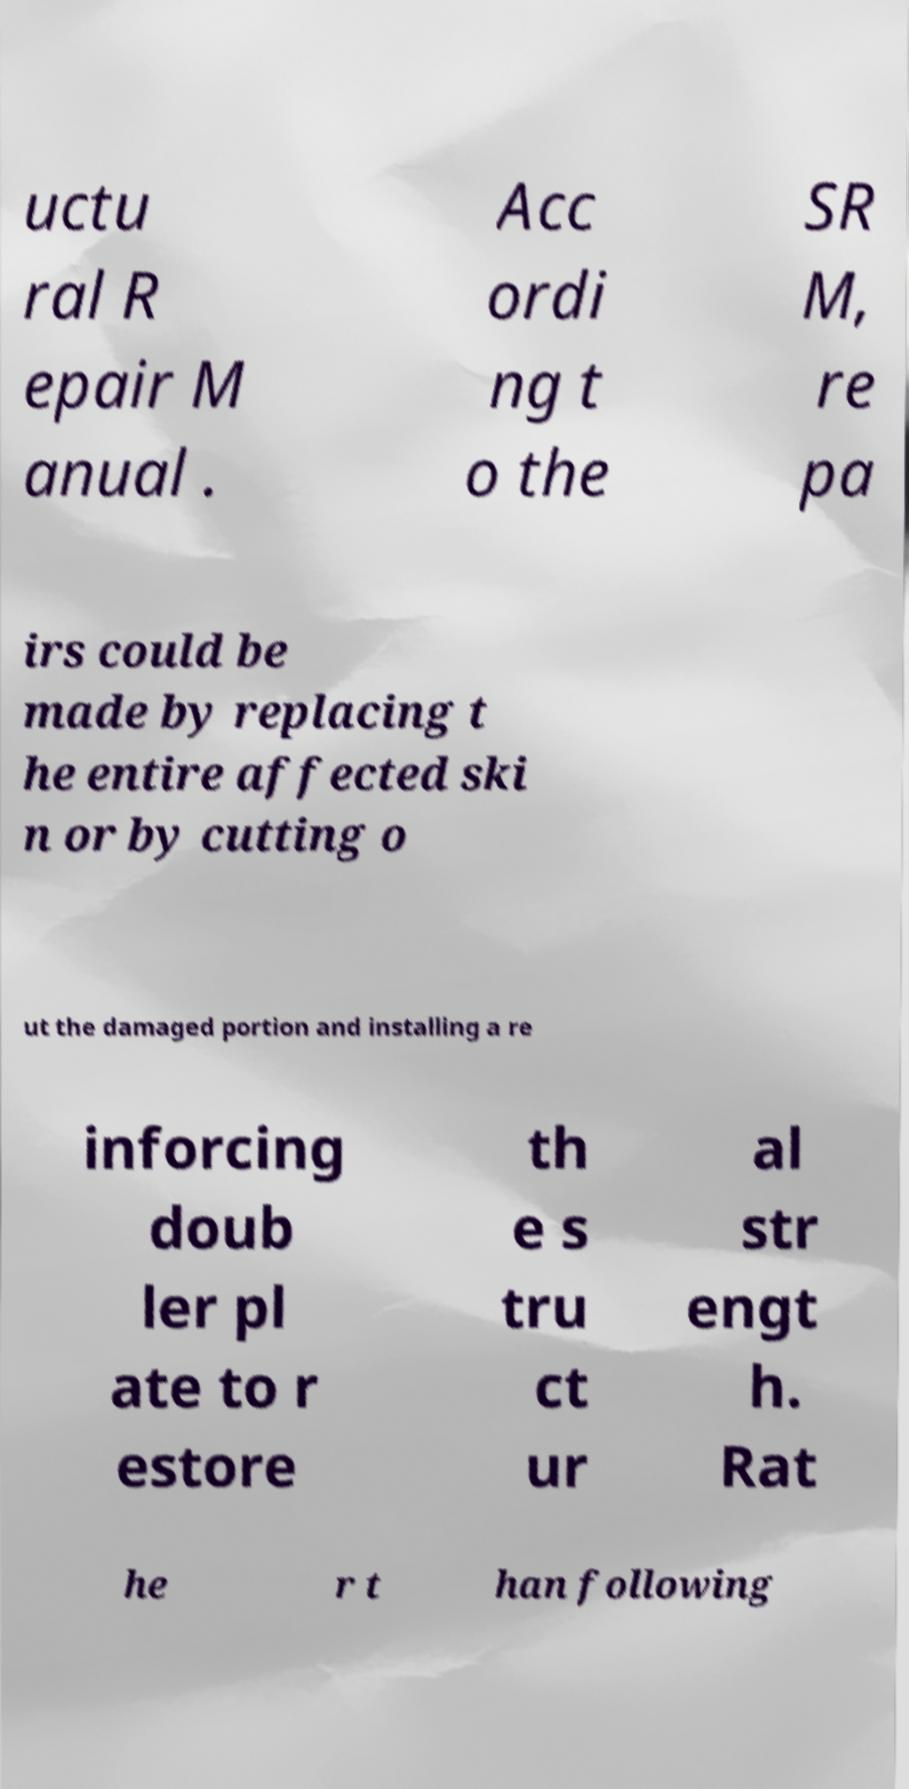What messages or text are displayed in this image? I need them in a readable, typed format. uctu ral R epair M anual . Acc ordi ng t o the SR M, re pa irs could be made by replacing t he entire affected ski n or by cutting o ut the damaged portion and installing a re inforcing doub ler pl ate to r estore th e s tru ct ur al str engt h. Rat he r t han following 